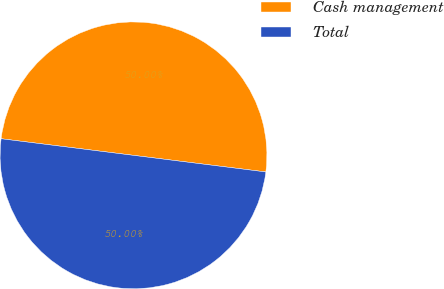Convert chart. <chart><loc_0><loc_0><loc_500><loc_500><pie_chart><fcel>Cash management<fcel>Total<nl><fcel>50.0%<fcel>50.0%<nl></chart> 